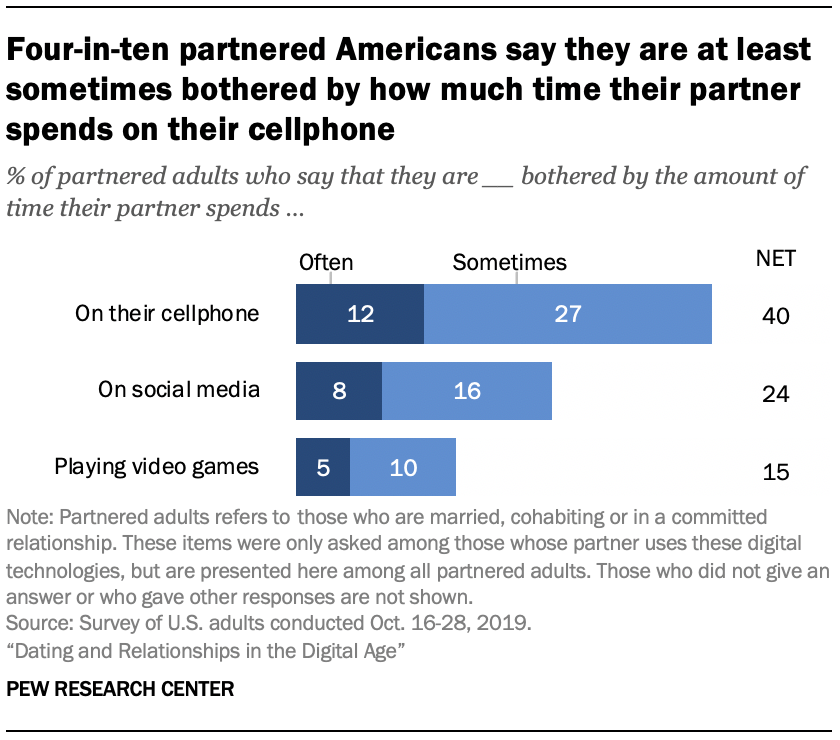Give some essential details in this illustration. The average of "net" is 26.33333333... which includes all the values. The value of the word "sometimes" on social media is 16. 